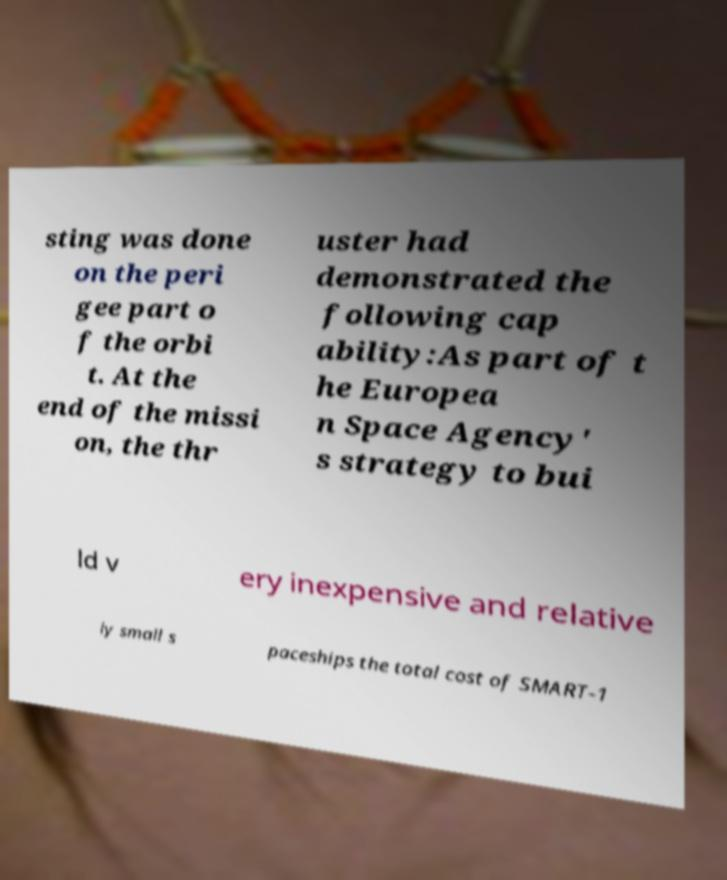Can you accurately transcribe the text from the provided image for me? sting was done on the peri gee part o f the orbi t. At the end of the missi on, the thr uster had demonstrated the following cap ability:As part of t he Europea n Space Agency' s strategy to bui ld v ery inexpensive and relative ly small s paceships the total cost of SMART-1 